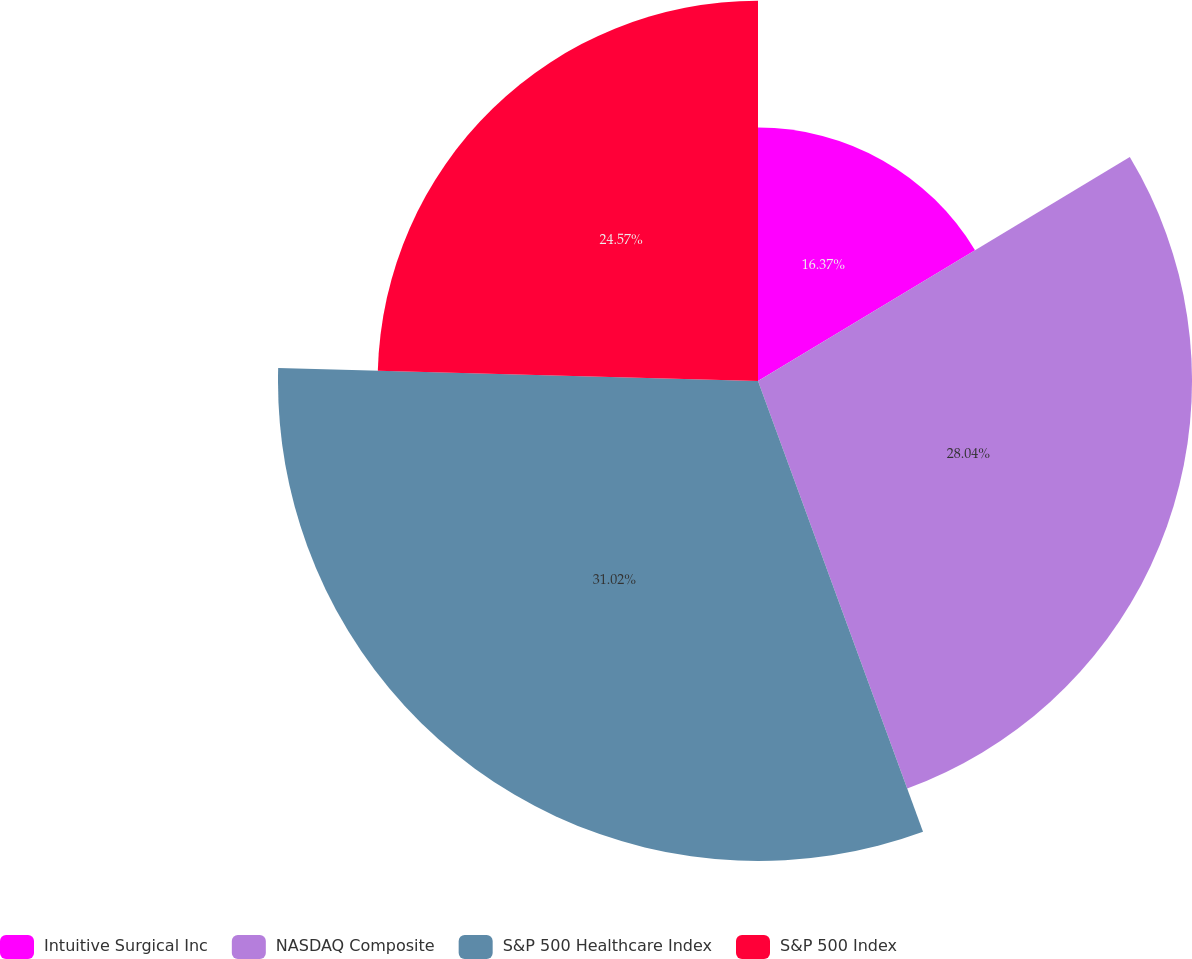Convert chart to OTSL. <chart><loc_0><loc_0><loc_500><loc_500><pie_chart><fcel>Intuitive Surgical Inc<fcel>NASDAQ Composite<fcel>S&P 500 Healthcare Index<fcel>S&P 500 Index<nl><fcel>16.37%<fcel>28.04%<fcel>31.01%<fcel>24.57%<nl></chart> 